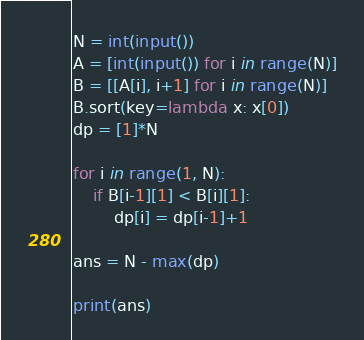Convert code to text. <code><loc_0><loc_0><loc_500><loc_500><_Python_>N = int(input())
A = [int(input()) for i in range(N)]
B = [[A[i], i+1] for i in range(N)]
B.sort(key=lambda x: x[0])
dp = [1]*N

for i in range(1, N):
    if B[i-1][1] < B[i][1]:
        dp[i] = dp[i-1]+1

ans = N - max(dp)

print(ans)
</code> 